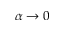Convert formula to latex. <formula><loc_0><loc_0><loc_500><loc_500>\alpha \rightarrow 0</formula> 